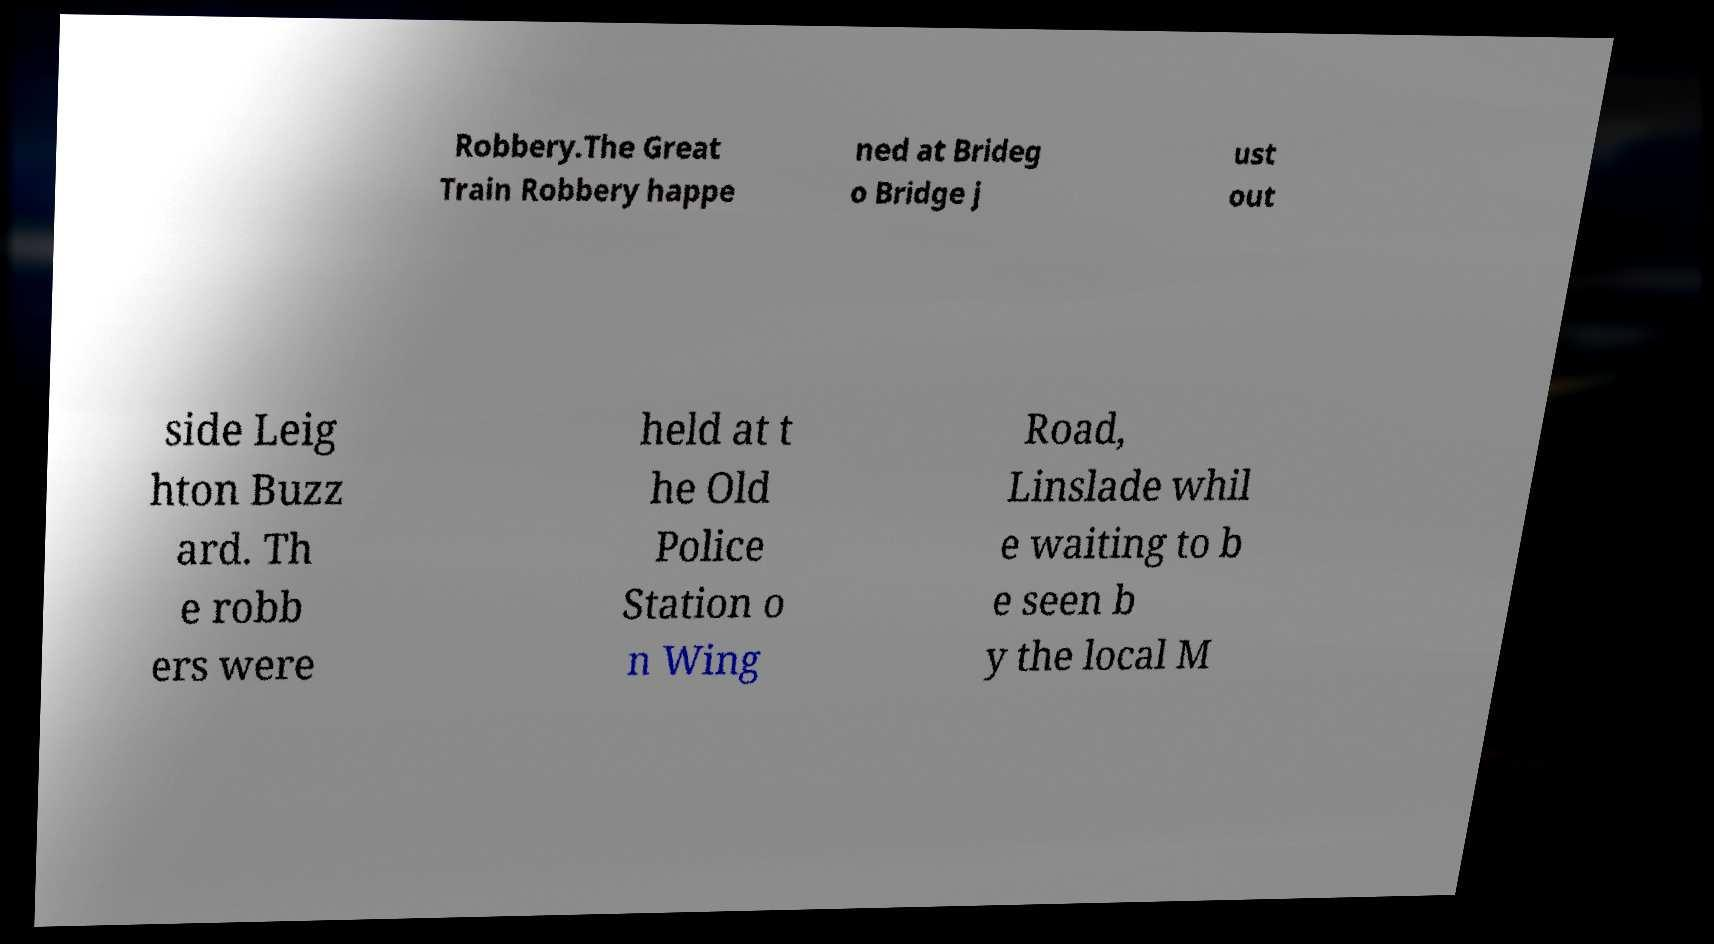There's text embedded in this image that I need extracted. Can you transcribe it verbatim? Robbery.The Great Train Robbery happe ned at Brideg o Bridge j ust out side Leig hton Buzz ard. Th e robb ers were held at t he Old Police Station o n Wing Road, Linslade whil e waiting to b e seen b y the local M 